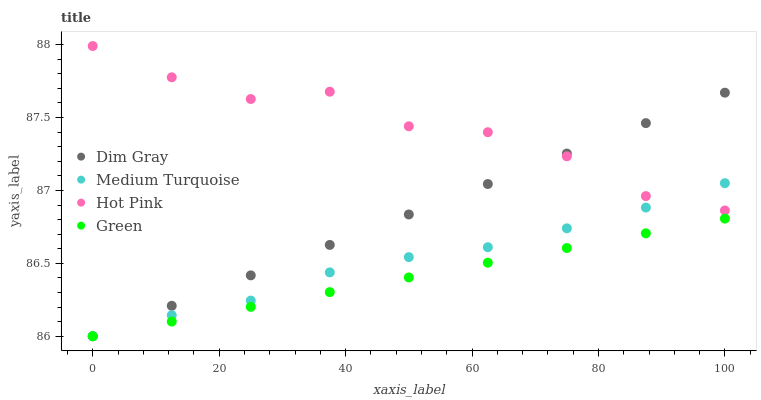Does Green have the minimum area under the curve?
Answer yes or no. Yes. Does Hot Pink have the maximum area under the curve?
Answer yes or no. Yes. Does Medium Turquoise have the minimum area under the curve?
Answer yes or no. No. Does Medium Turquoise have the maximum area under the curve?
Answer yes or no. No. Is Green the smoothest?
Answer yes or no. Yes. Is Hot Pink the roughest?
Answer yes or no. Yes. Is Medium Turquoise the smoothest?
Answer yes or no. No. Is Medium Turquoise the roughest?
Answer yes or no. No. Does Dim Gray have the lowest value?
Answer yes or no. Yes. Does Hot Pink have the lowest value?
Answer yes or no. No. Does Hot Pink have the highest value?
Answer yes or no. Yes. Does Medium Turquoise have the highest value?
Answer yes or no. No. Is Green less than Hot Pink?
Answer yes or no. Yes. Is Hot Pink greater than Green?
Answer yes or no. Yes. Does Dim Gray intersect Green?
Answer yes or no. Yes. Is Dim Gray less than Green?
Answer yes or no. No. Is Dim Gray greater than Green?
Answer yes or no. No. Does Green intersect Hot Pink?
Answer yes or no. No. 